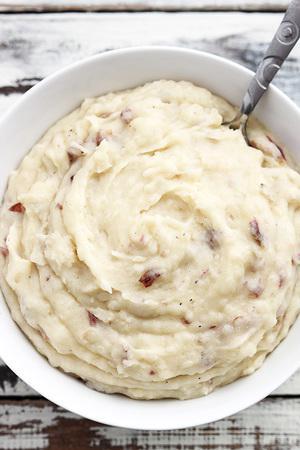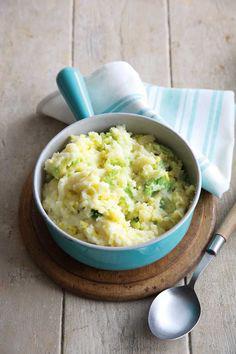The first image is the image on the left, the second image is the image on the right. For the images shown, is this caption "A silver spoon is set near the dish on the right." true? Answer yes or no. Yes. The first image is the image on the left, the second image is the image on the right. Analyze the images presented: Is the assertion "The left image shows a white bowl of food with a utensil handle sticking out, and the right image includes a spoon that is not sticking out of the food." valid? Answer yes or no. Yes. 